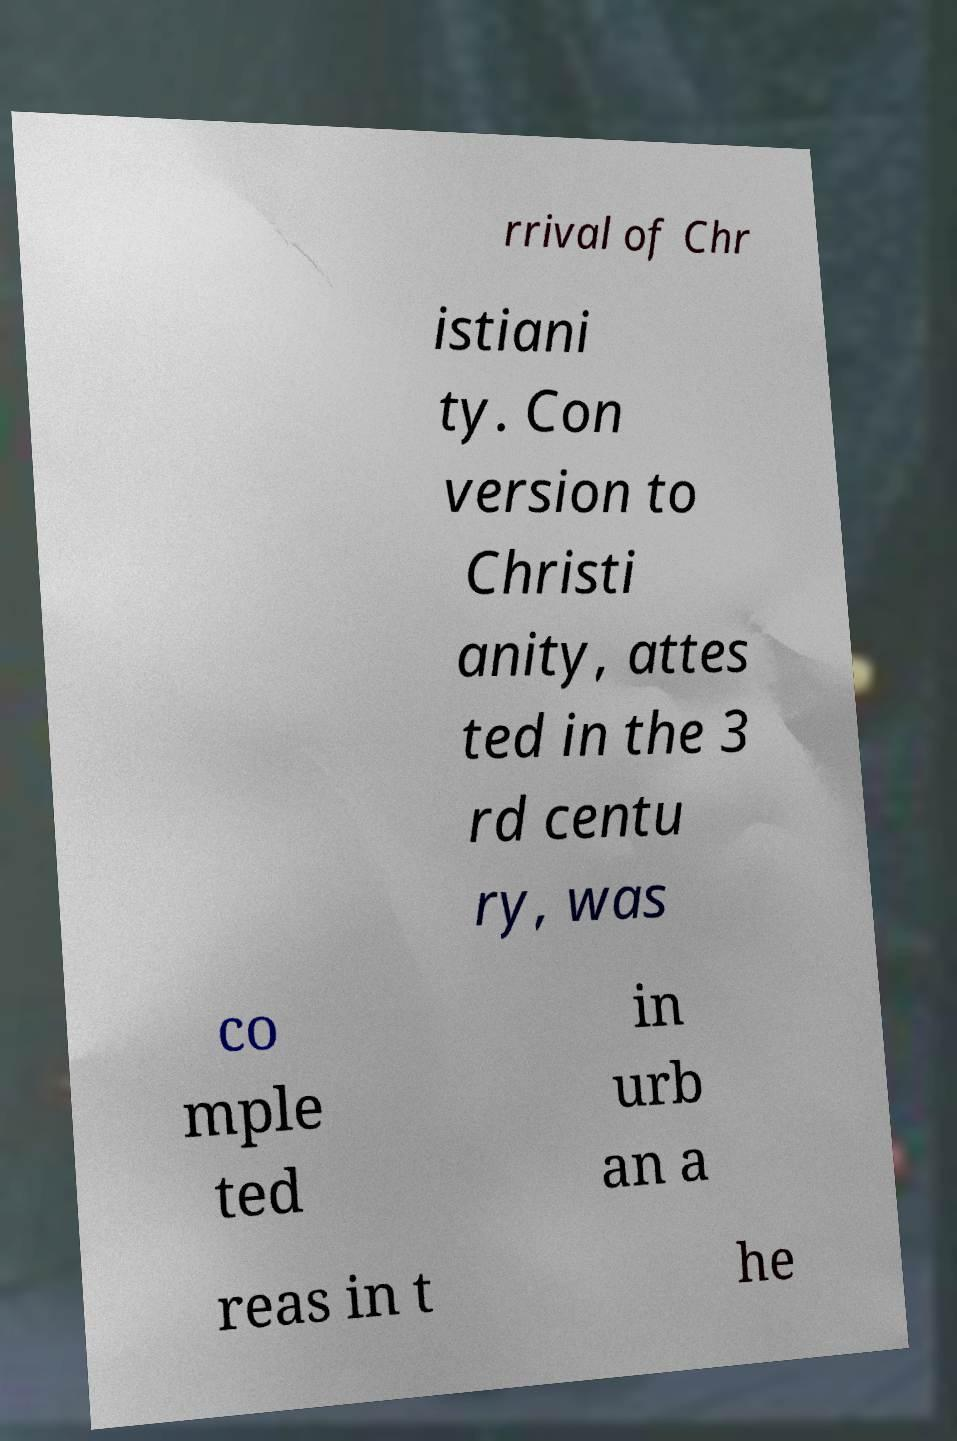Could you extract and type out the text from this image? rrival of Chr istiani ty. Con version to Christi anity, attes ted in the 3 rd centu ry, was co mple ted in urb an a reas in t he 